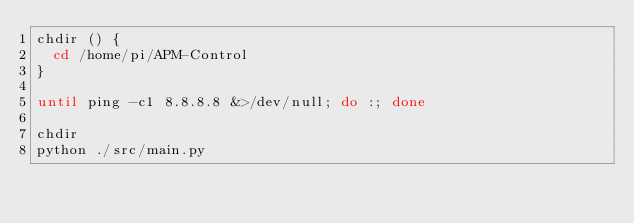<code> <loc_0><loc_0><loc_500><loc_500><_Bash_>chdir () {
  cd /home/pi/APM-Control
}

until ping -c1 8.8.8.8 &>/dev/null; do :; done

chdir
python ./src/main.py
</code> 